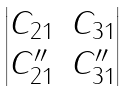Convert formula to latex. <formula><loc_0><loc_0><loc_500><loc_500>\begin{vmatrix} C _ { 2 1 } & C _ { 3 1 } \\ C ^ { \prime \prime } _ { 2 1 } & C ^ { \prime \prime } _ { 3 1 } \end{vmatrix}</formula> 